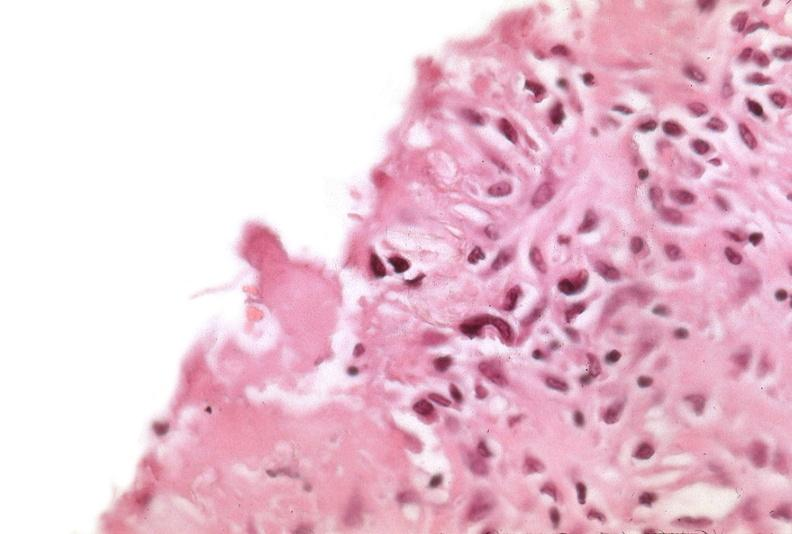s lymphoblastic lymphoma present?
Answer the question using a single word or phrase. No 